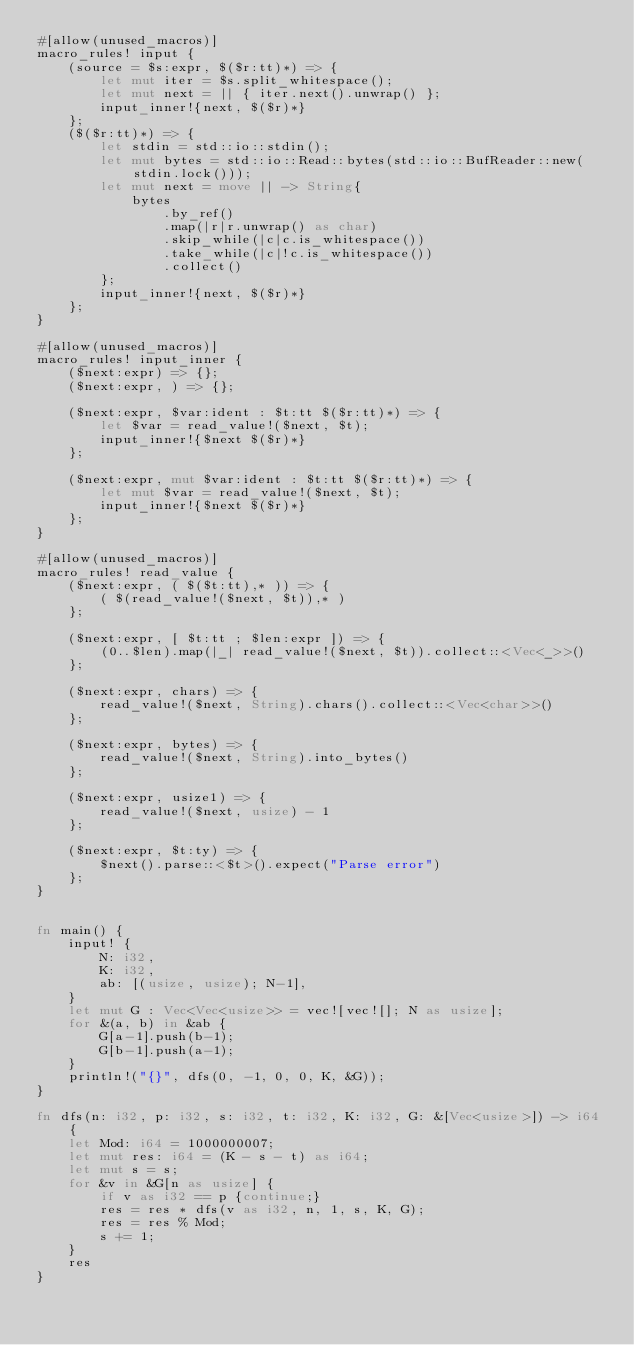<code> <loc_0><loc_0><loc_500><loc_500><_Rust_>#[allow(unused_macros)]
macro_rules! input {
    (source = $s:expr, $($r:tt)*) => {
        let mut iter = $s.split_whitespace();
        let mut next = || { iter.next().unwrap() };
        input_inner!{next, $($r)*}
    };
    ($($r:tt)*) => {
        let stdin = std::io::stdin();
        let mut bytes = std::io::Read::bytes(std::io::BufReader::new(stdin.lock()));
        let mut next = move || -> String{
            bytes
                .by_ref()
                .map(|r|r.unwrap() as char)
                .skip_while(|c|c.is_whitespace())
                .take_while(|c|!c.is_whitespace())
                .collect()
        };
        input_inner!{next, $($r)*}
    };
}
 
#[allow(unused_macros)]
macro_rules! input_inner {
    ($next:expr) => {};
    ($next:expr, ) => {};
 
    ($next:expr, $var:ident : $t:tt $($r:tt)*) => {
        let $var = read_value!($next, $t);
        input_inner!{$next $($r)*}
    };
 
    ($next:expr, mut $var:ident : $t:tt $($r:tt)*) => {
        let mut $var = read_value!($next, $t);
        input_inner!{$next $($r)*}
    };
}
 
#[allow(unused_macros)]
macro_rules! read_value {
    ($next:expr, ( $($t:tt),* )) => {
        ( $(read_value!($next, $t)),* )
    };
 
    ($next:expr, [ $t:tt ; $len:expr ]) => {
        (0..$len).map(|_| read_value!($next, $t)).collect::<Vec<_>>()
    };
 
    ($next:expr, chars) => {
        read_value!($next, String).chars().collect::<Vec<char>>()
    };
 
    ($next:expr, bytes) => {
        read_value!($next, String).into_bytes()
    };
 
    ($next:expr, usize1) => {
        read_value!($next, usize) - 1
    };
 
    ($next:expr, $t:ty) => {
        $next().parse::<$t>().expect("Parse error")
    };
}


fn main() {
    input! {
        N: i32,
        K: i32,
		ab: [(usize, usize); N-1],
    }
	let mut G : Vec<Vec<usize>> = vec![vec![]; N as usize]; 
	for &(a, b) in &ab {
		G[a-1].push(b-1);
		G[b-1].push(a-1);
	}
	println!("{}", dfs(0, -1, 0, 0, K, &G));
}

fn dfs(n: i32, p: i32, s: i32, t: i32, K: i32, G: &[Vec<usize>]) -> i64 {
	let Mod: i64 = 1000000007;
	let mut res: i64 = (K - s - t) as i64;
	let mut s = s;
	for &v in &G[n as usize] {
		if v as i32 == p {continue;}
		res = res * dfs(v as i32, n, 1, s, K, G);
		res = res % Mod;
		s += 1;
	}
	res
}</code> 